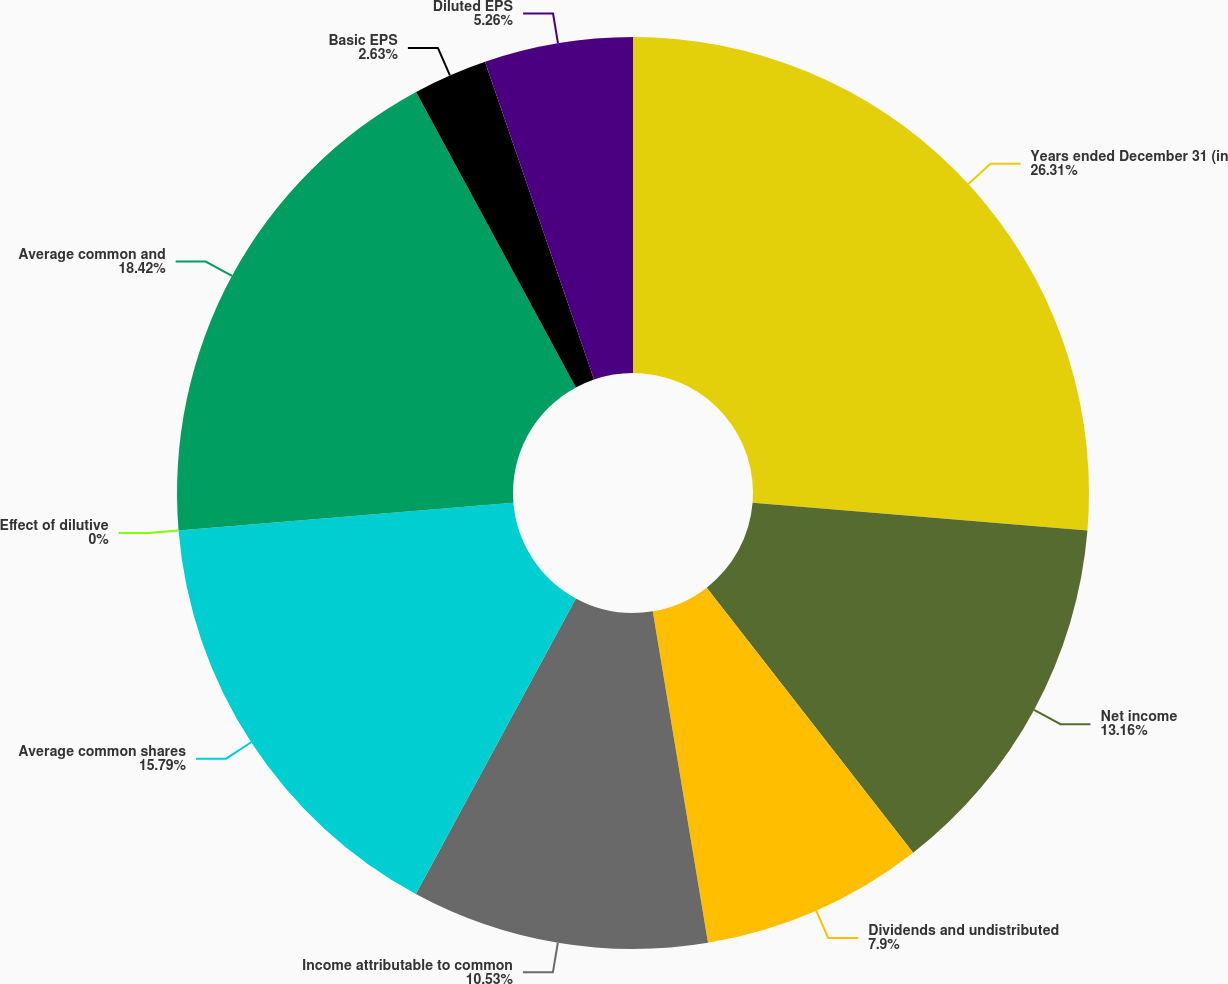<chart> <loc_0><loc_0><loc_500><loc_500><pie_chart><fcel>Years ended December 31 (in<fcel>Net income<fcel>Dividends and undistributed<fcel>Income attributable to common<fcel>Average common shares<fcel>Effect of dilutive<fcel>Average common and<fcel>Basic EPS<fcel>Diluted EPS<nl><fcel>26.31%<fcel>13.16%<fcel>7.9%<fcel>10.53%<fcel>15.79%<fcel>0.0%<fcel>18.42%<fcel>2.63%<fcel>5.26%<nl></chart> 